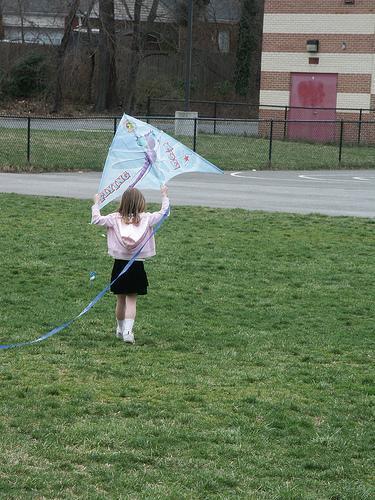How many kites are in the air?
Give a very brief answer. 0. 